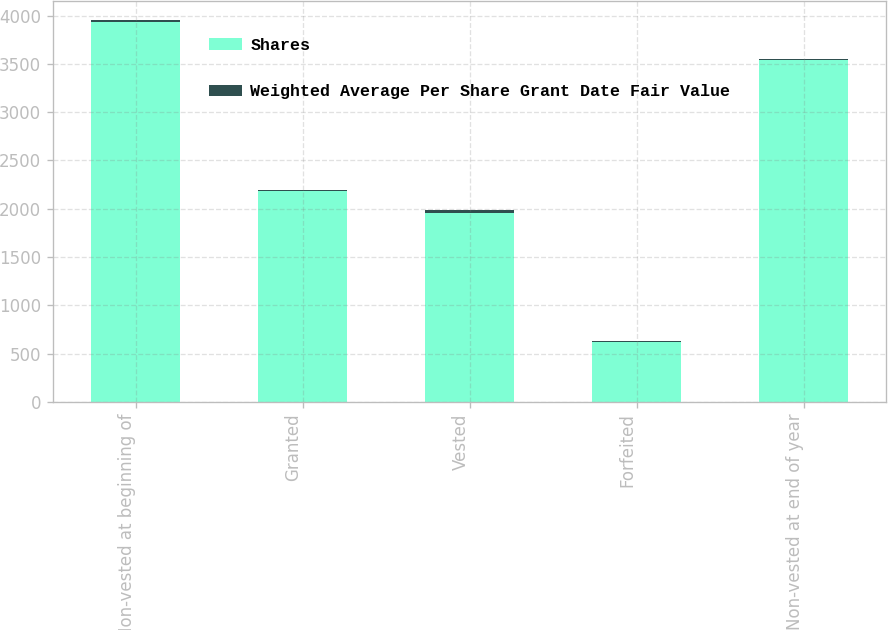Convert chart. <chart><loc_0><loc_0><loc_500><loc_500><stacked_bar_chart><ecel><fcel>Non-vested at beginning of<fcel>Granted<fcel>Vested<fcel>Forfeited<fcel>Non-vested at end of year<nl><fcel>Shares<fcel>3932<fcel>2182<fcel>1957<fcel>618<fcel>3539<nl><fcel>Weighted Average Per Share Grant Date Fair Value<fcel>23<fcel>12<fcel>25<fcel>14<fcel>16<nl></chart> 